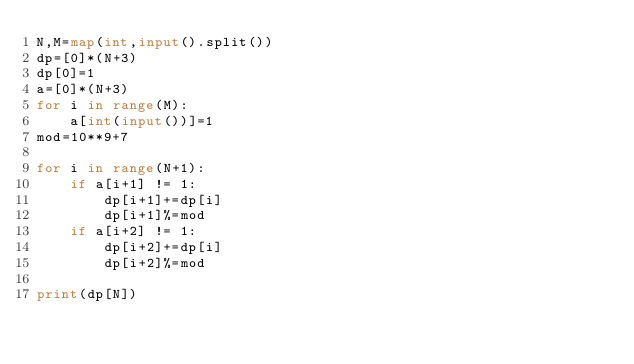<code> <loc_0><loc_0><loc_500><loc_500><_Python_>N,M=map(int,input().split())
dp=[0]*(N+3)
dp[0]=1
a=[0]*(N+3)
for i in range(M):
    a[int(input())]=1
mod=10**9+7

for i in range(N+1):
    if a[i+1] != 1:
        dp[i+1]+=dp[i]
        dp[i+1]%=mod
    if a[i+2] != 1:
        dp[i+2]+=dp[i]
        dp[i+2]%=mod

print(dp[N])</code> 